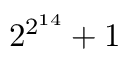<formula> <loc_0><loc_0><loc_500><loc_500>2 ^ { 2 ^ { 1 4 } } + 1</formula> 